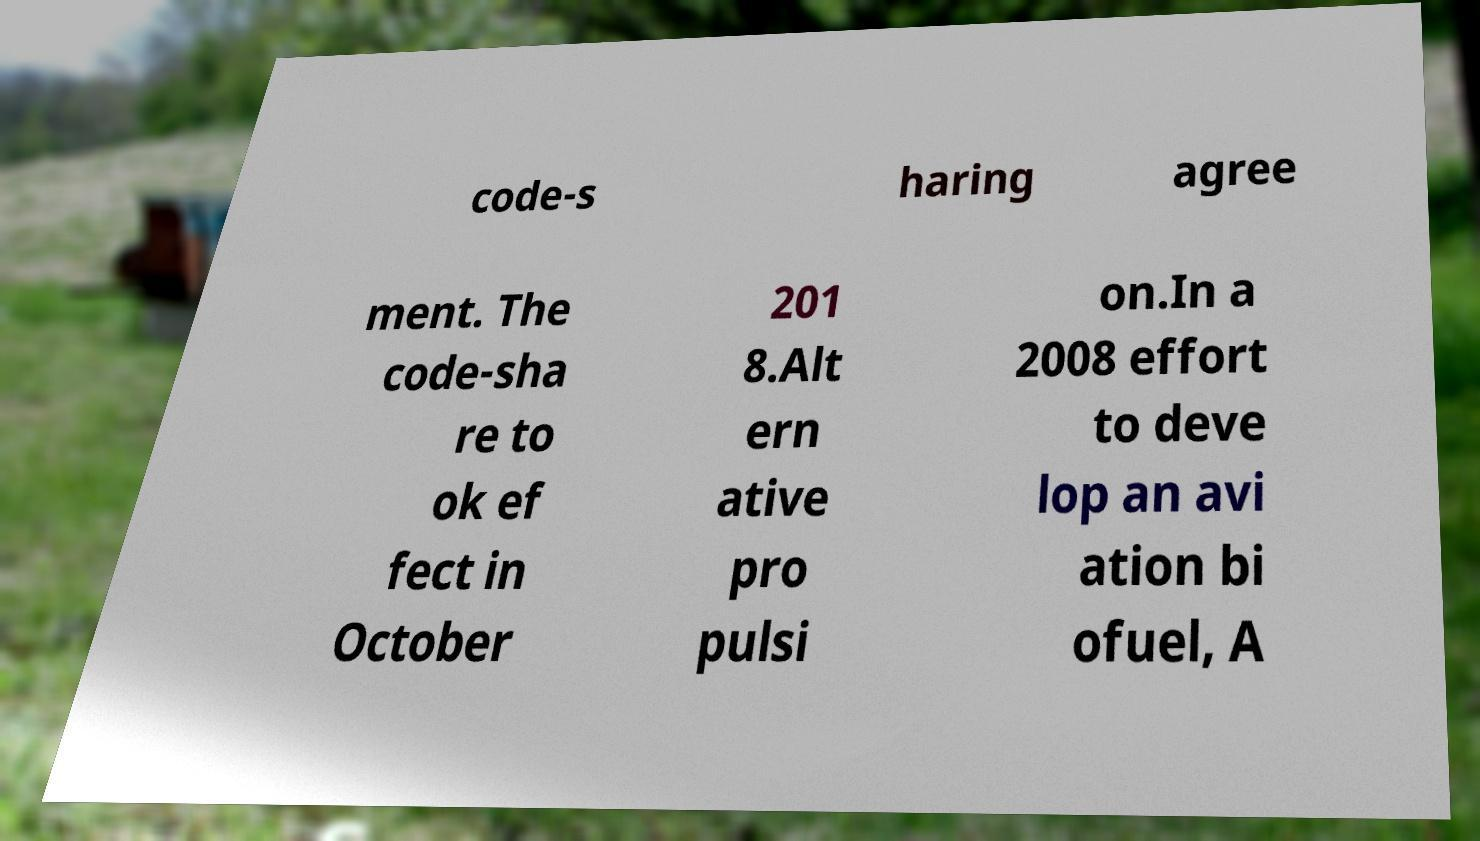Please identify and transcribe the text found in this image. code-s haring agree ment. The code-sha re to ok ef fect in October 201 8.Alt ern ative pro pulsi on.In a 2008 effort to deve lop an avi ation bi ofuel, A 